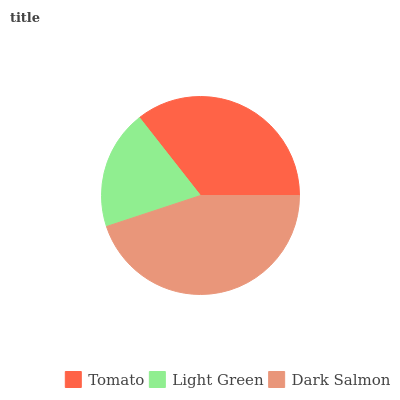Is Light Green the minimum?
Answer yes or no. Yes. Is Dark Salmon the maximum?
Answer yes or no. Yes. Is Dark Salmon the minimum?
Answer yes or no. No. Is Light Green the maximum?
Answer yes or no. No. Is Dark Salmon greater than Light Green?
Answer yes or no. Yes. Is Light Green less than Dark Salmon?
Answer yes or no. Yes. Is Light Green greater than Dark Salmon?
Answer yes or no. No. Is Dark Salmon less than Light Green?
Answer yes or no. No. Is Tomato the high median?
Answer yes or no. Yes. Is Tomato the low median?
Answer yes or no. Yes. Is Dark Salmon the high median?
Answer yes or no. No. Is Dark Salmon the low median?
Answer yes or no. No. 